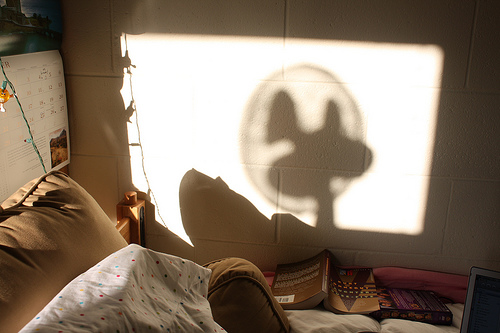<image>
Is there a shadow on the book? No. The shadow is not positioned on the book. They may be near each other, but the shadow is not supported by or resting on top of the book. 